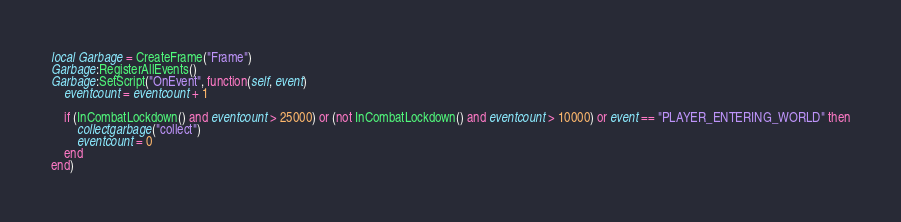Convert code to text. <code><loc_0><loc_0><loc_500><loc_500><_Lua_>local Garbage = CreateFrame("Frame")
Garbage:RegisterAllEvents()
Garbage:SetScript("OnEvent", function(self, event)
	eventcount = eventcount + 1

	if (InCombatLockdown() and eventcount > 25000) or (not InCombatLockdown() and eventcount > 10000) or event == "PLAYER_ENTERING_WORLD" then
		collectgarbage("collect")
		eventcount = 0
	end
end)</code> 